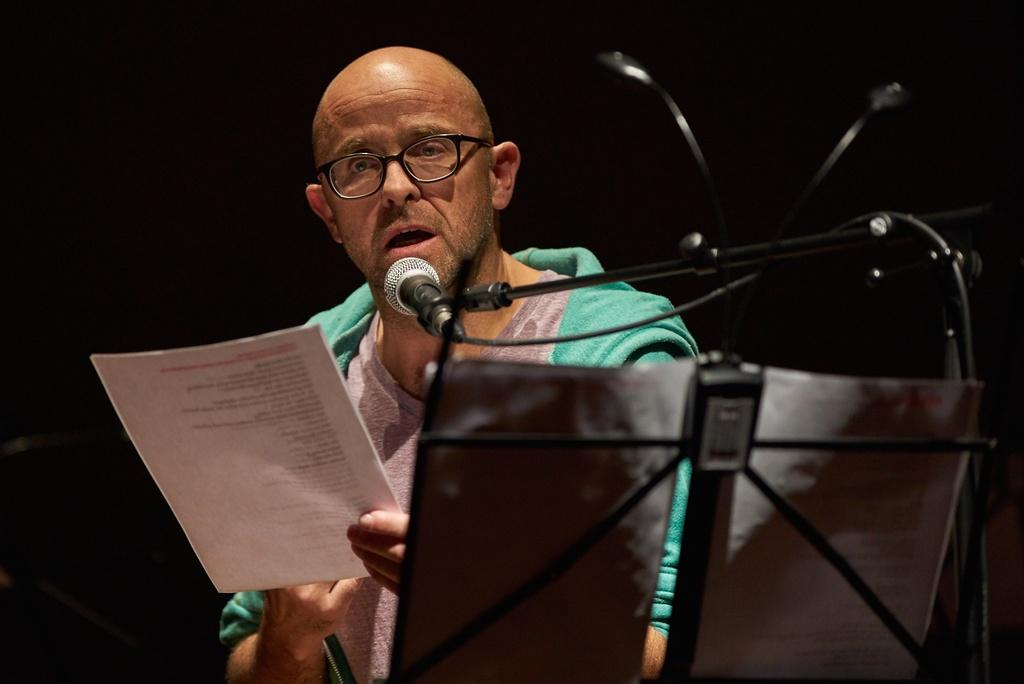What is the main subject of the image? There is a person in the image. What is the person wearing? The person is wearing a dress. What is the person holding in the image? The person is holding a paper. What can be seen in front of the person? There is a black color stand in front of the person. What is on the stand? There is a microphone on the stand, and there are papers on the stand. How many brothers does the person in the image have? There is no information about the person's brothers in the image. Can you see a door in the image? There is no door visible in the image. 